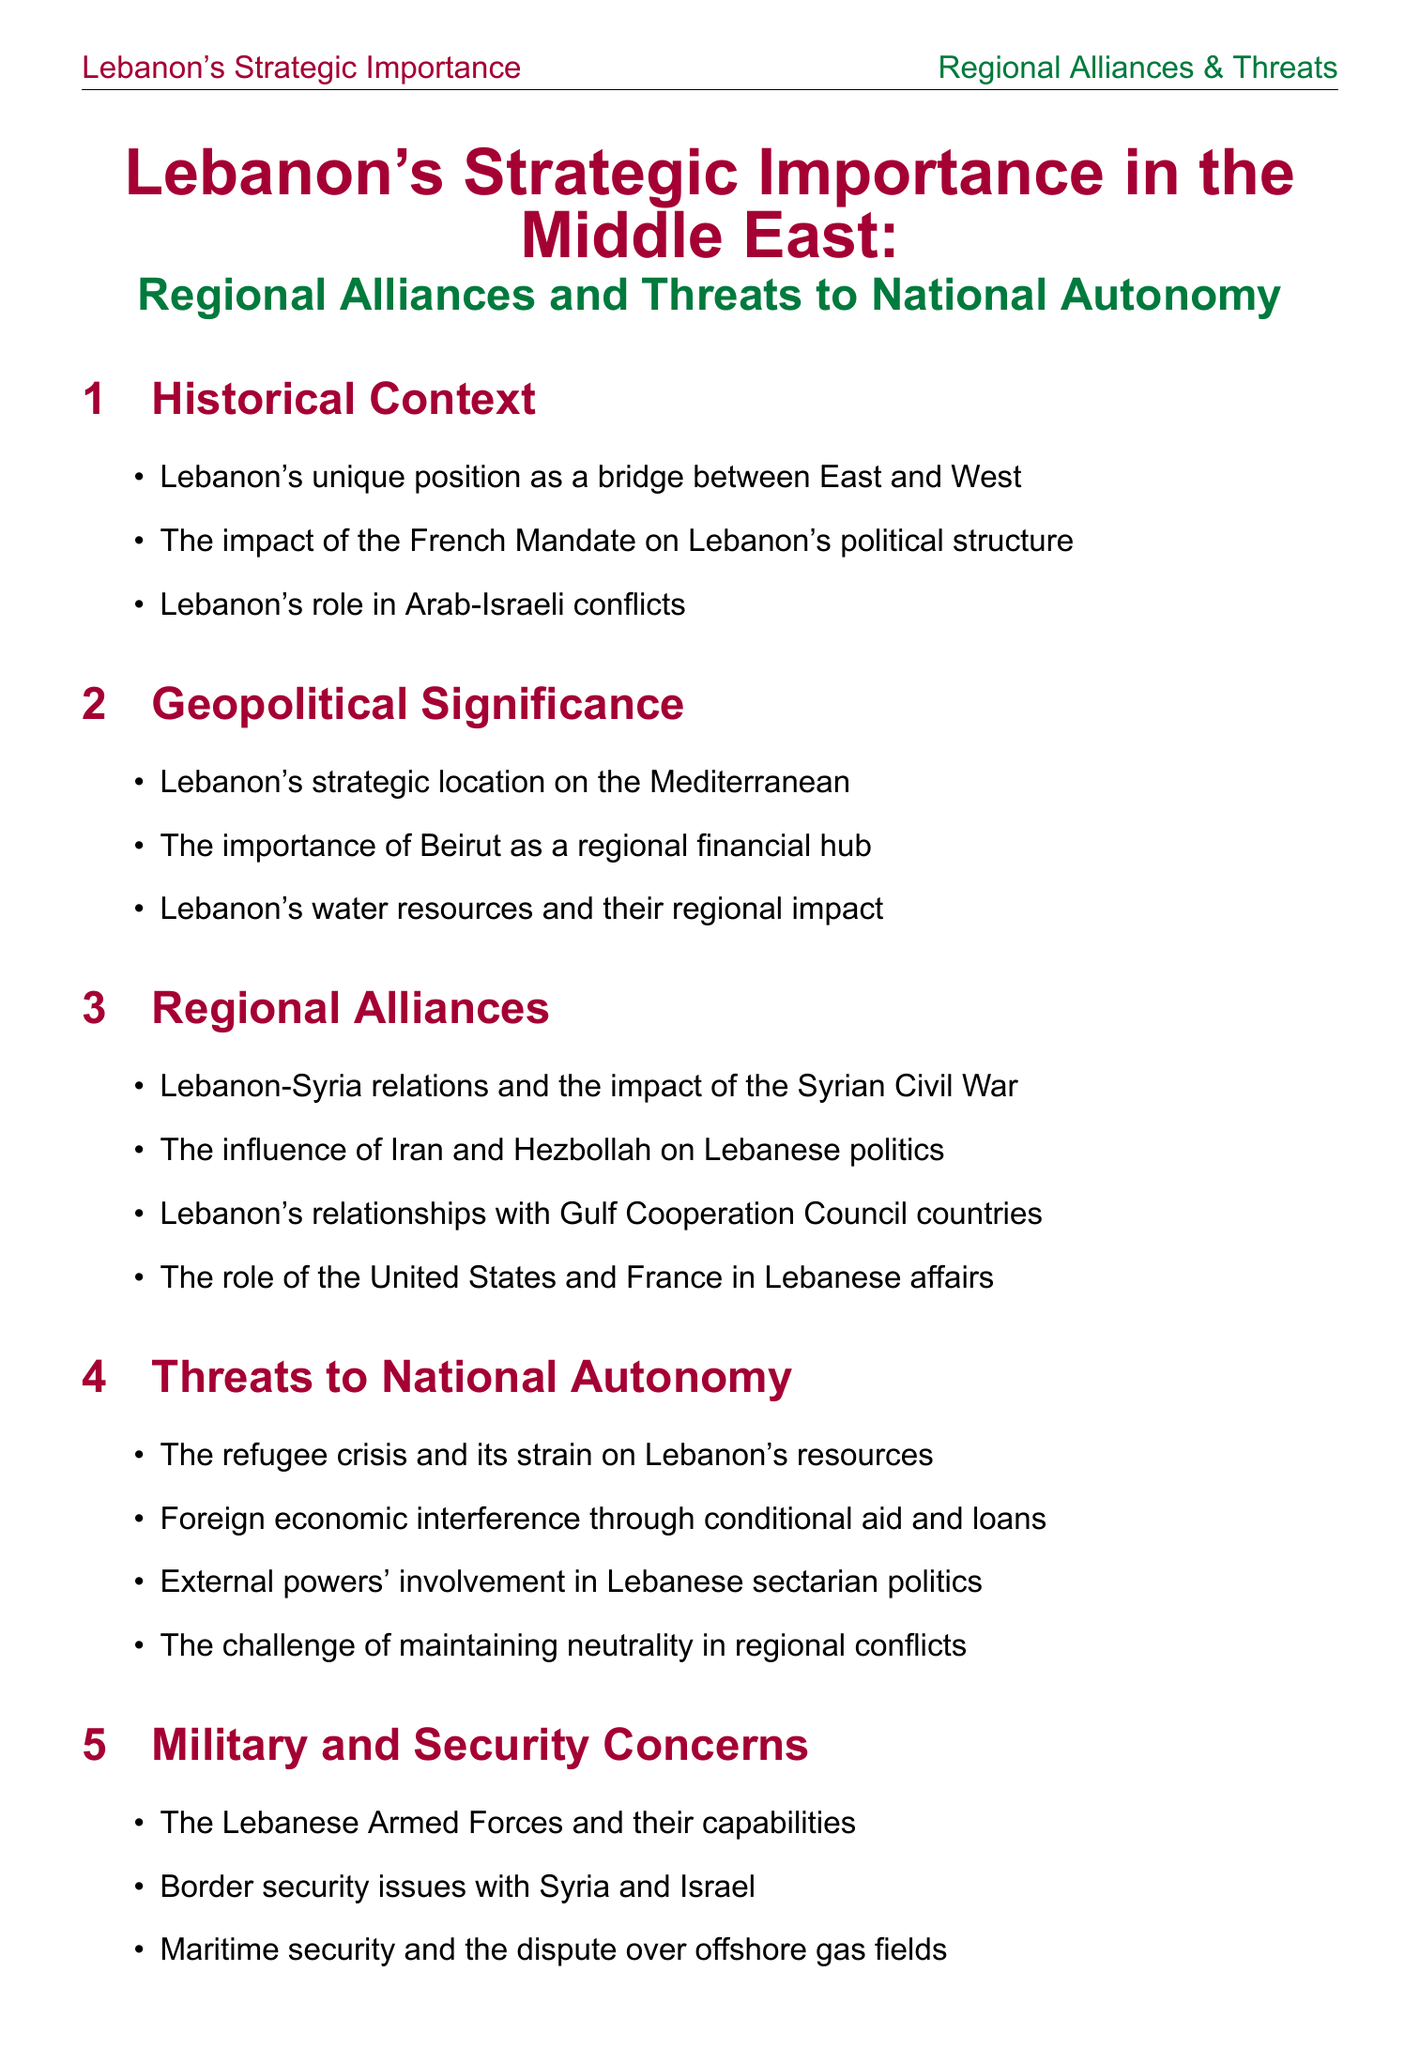what is Lebanon's strategic location? Lebanon is strategically located on the Mediterranean.
Answer: Mediterranean who is the leader of Hezbollah? The document states that Hassan Nasrallah is the Secretary-General of Hezbollah.
Answer: Hassan Nasrallah which country has influenced Lebanese politics according to the document? The influence of Iran and Hezbollah on Lebanese politics is highlighted in the document.
Answer: Iran and Hezbollah what year did the Cedar Revolution occur? The important events section mentions that the Cedar Revolution took place in 2005.
Answer: 2005 what is a major concern listed regarding Lebanon's national autonomy? The document identifies foreign economic interference through conditional aid and loans as a threat to national autonomy.
Answer: Foreign economic interference how many regional actors are mentioned in the document? The regional actors section lists a total of eight countries.
Answer: Eight what are Lebanon's water resources described as? The document states that Lebanon's water resources have a regional impact.
Answer: Regional impact what is the challenge Lebanon faces in maintaining its neutrality? The document highlights maintaining neutrality in regional conflicts as a challenge.
Answer: Maintaining neutrality in regional conflicts who is the President of Lebanon? The document states that Michel Aoun is the President of Lebanon.
Answer: Michel Aoun 